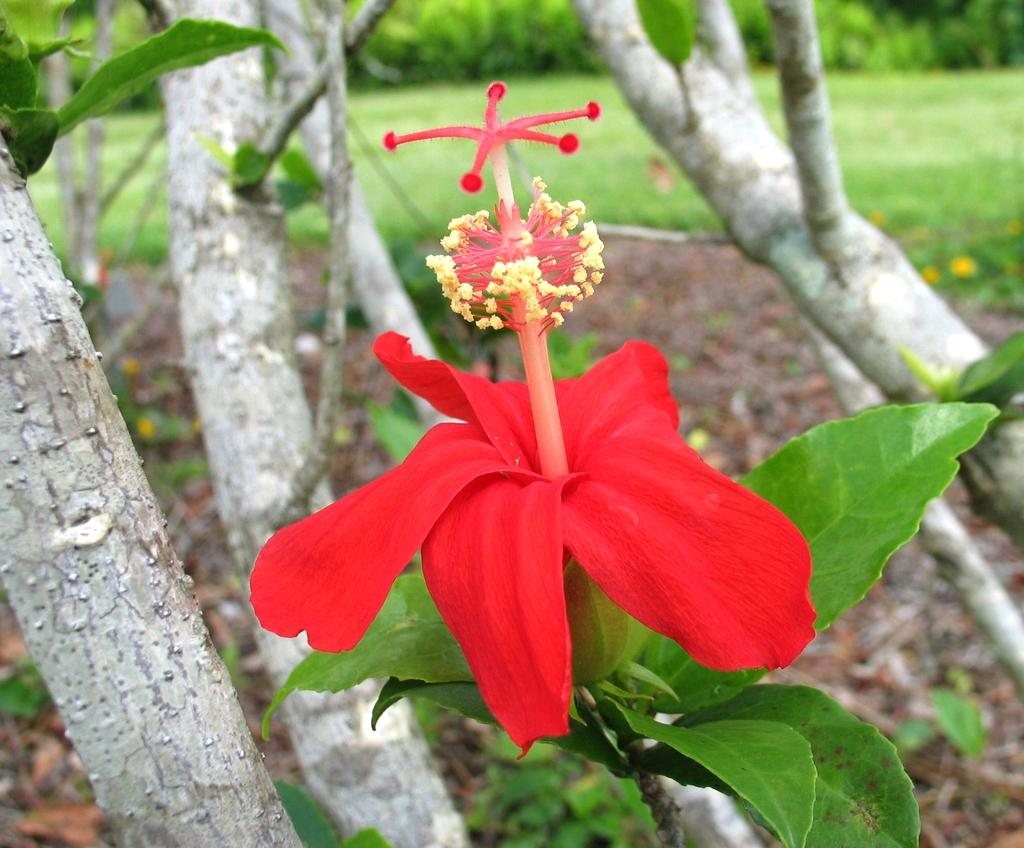What is the main subject in the middle of the image? There is a flower in the middle of the image. What other natural elements can be seen in the image? There are trees in the image. Where is the playground located in the image? There is no playground present in the image. What type of prison can be seen in the image? There is no prison present in the image. 